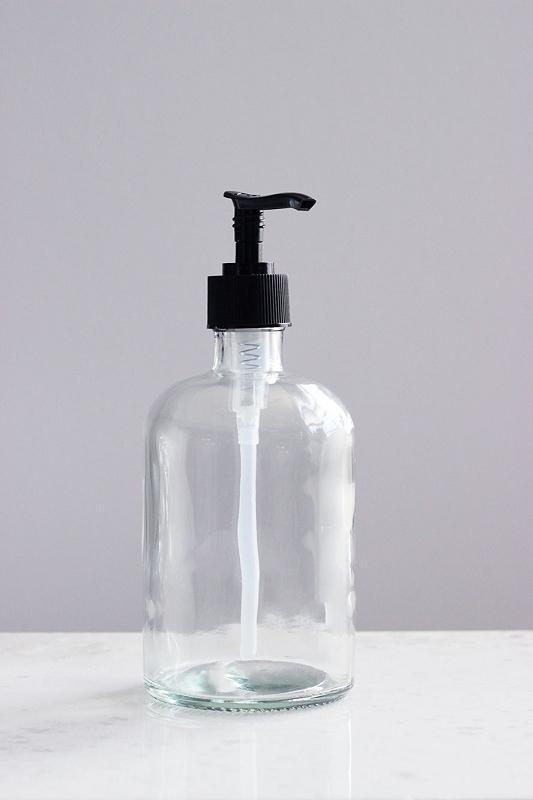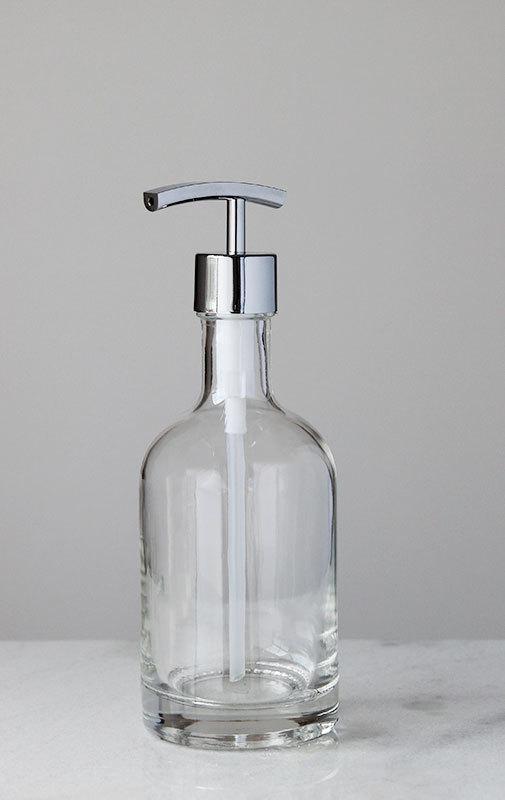The first image is the image on the left, the second image is the image on the right. For the images displayed, is the sentence "One image shows a single pump-top dispenser, which is opaque white and has a left-facing nozzle." factually correct? Answer yes or no. No. The first image is the image on the left, the second image is the image on the right. Considering the images on both sides, is "There are more containers in the image on the left." valid? Answer yes or no. No. 